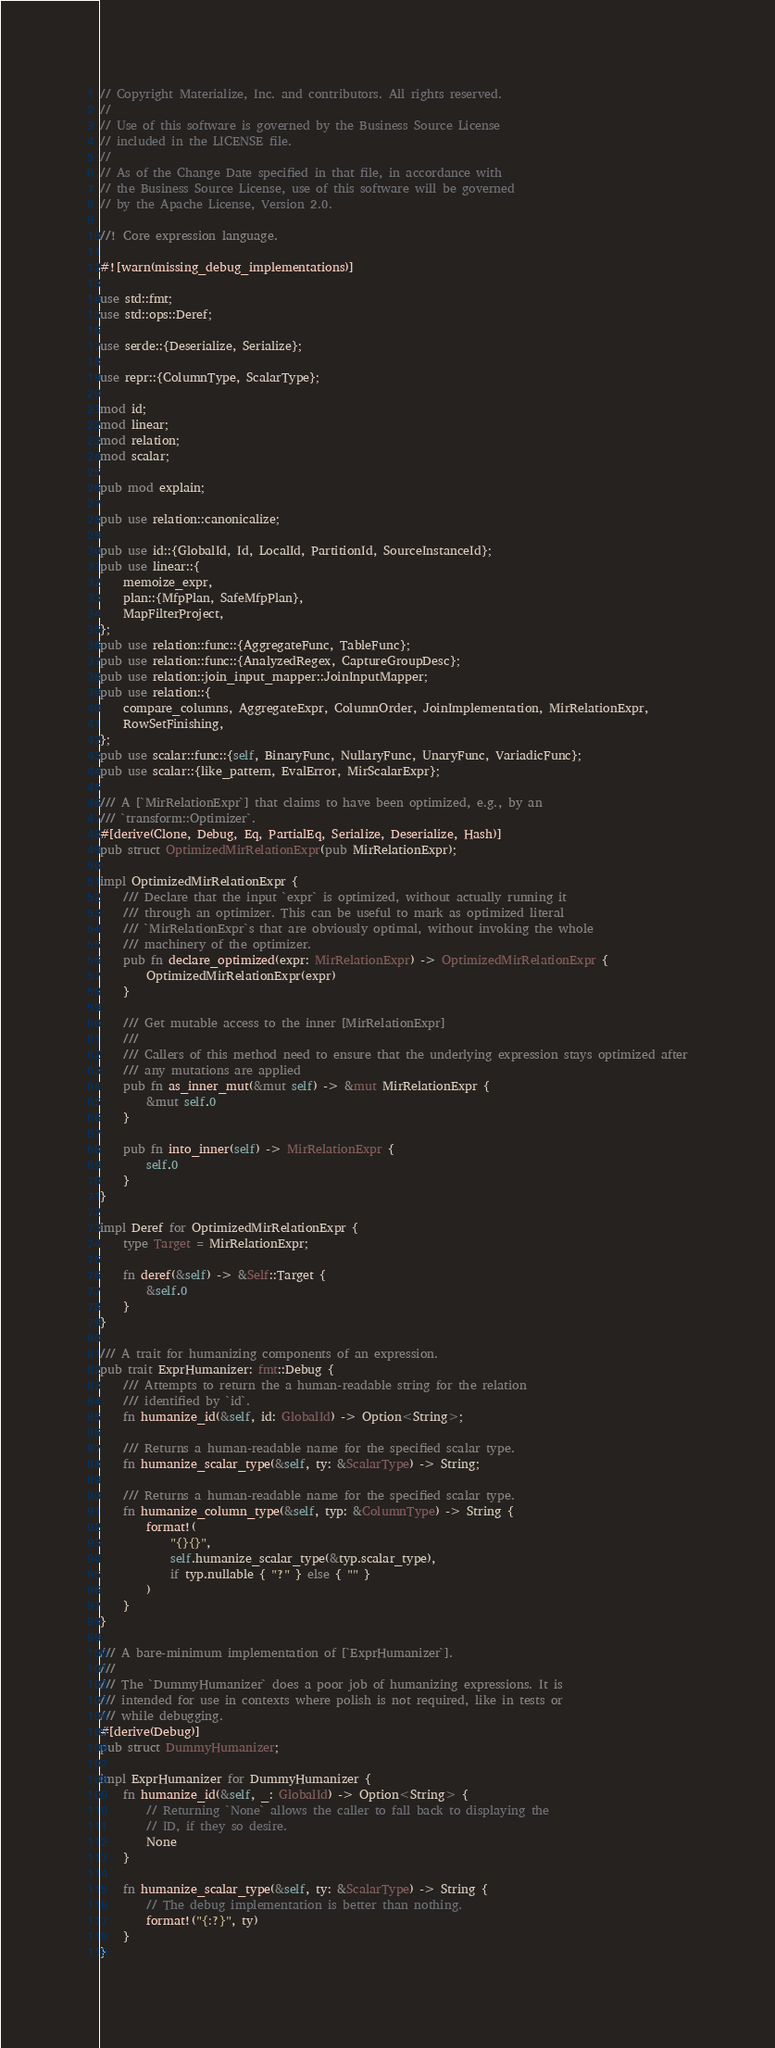<code> <loc_0><loc_0><loc_500><loc_500><_Rust_>// Copyright Materialize, Inc. and contributors. All rights reserved.
//
// Use of this software is governed by the Business Source License
// included in the LICENSE file.
//
// As of the Change Date specified in that file, in accordance with
// the Business Source License, use of this software will be governed
// by the Apache License, Version 2.0.

//! Core expression language.

#![warn(missing_debug_implementations)]

use std::fmt;
use std::ops::Deref;

use serde::{Deserialize, Serialize};

use repr::{ColumnType, ScalarType};

mod id;
mod linear;
mod relation;
mod scalar;

pub mod explain;

pub use relation::canonicalize;

pub use id::{GlobalId, Id, LocalId, PartitionId, SourceInstanceId};
pub use linear::{
    memoize_expr,
    plan::{MfpPlan, SafeMfpPlan},
    MapFilterProject,
};
pub use relation::func::{AggregateFunc, TableFunc};
pub use relation::func::{AnalyzedRegex, CaptureGroupDesc};
pub use relation::join_input_mapper::JoinInputMapper;
pub use relation::{
    compare_columns, AggregateExpr, ColumnOrder, JoinImplementation, MirRelationExpr,
    RowSetFinishing,
};
pub use scalar::func::{self, BinaryFunc, NullaryFunc, UnaryFunc, VariadicFunc};
pub use scalar::{like_pattern, EvalError, MirScalarExpr};

/// A [`MirRelationExpr`] that claims to have been optimized, e.g., by an
/// `transform::Optimizer`.
#[derive(Clone, Debug, Eq, PartialEq, Serialize, Deserialize, Hash)]
pub struct OptimizedMirRelationExpr(pub MirRelationExpr);

impl OptimizedMirRelationExpr {
    /// Declare that the input `expr` is optimized, without actually running it
    /// through an optimizer. This can be useful to mark as optimized literal
    /// `MirRelationExpr`s that are obviously optimal, without invoking the whole
    /// machinery of the optimizer.
    pub fn declare_optimized(expr: MirRelationExpr) -> OptimizedMirRelationExpr {
        OptimizedMirRelationExpr(expr)
    }

    /// Get mutable access to the inner [MirRelationExpr]
    ///
    /// Callers of this method need to ensure that the underlying expression stays optimized after
    /// any mutations are applied
    pub fn as_inner_mut(&mut self) -> &mut MirRelationExpr {
        &mut self.0
    }

    pub fn into_inner(self) -> MirRelationExpr {
        self.0
    }
}

impl Deref for OptimizedMirRelationExpr {
    type Target = MirRelationExpr;

    fn deref(&self) -> &Self::Target {
        &self.0
    }
}

/// A trait for humanizing components of an expression.
pub trait ExprHumanizer: fmt::Debug {
    /// Attempts to return the a human-readable string for the relation
    /// identified by `id`.
    fn humanize_id(&self, id: GlobalId) -> Option<String>;

    /// Returns a human-readable name for the specified scalar type.
    fn humanize_scalar_type(&self, ty: &ScalarType) -> String;

    /// Returns a human-readable name for the specified scalar type.
    fn humanize_column_type(&self, typ: &ColumnType) -> String {
        format!(
            "{}{}",
            self.humanize_scalar_type(&typ.scalar_type),
            if typ.nullable { "?" } else { "" }
        )
    }
}

/// A bare-minimum implementation of [`ExprHumanizer`].
///
/// The `DummyHumanizer` does a poor job of humanizing expressions. It is
/// intended for use in contexts where polish is not required, like in tests or
/// while debugging.
#[derive(Debug)]
pub struct DummyHumanizer;

impl ExprHumanizer for DummyHumanizer {
    fn humanize_id(&self, _: GlobalId) -> Option<String> {
        // Returning `None` allows the caller to fall back to displaying the
        // ID, if they so desire.
        None
    }

    fn humanize_scalar_type(&self, ty: &ScalarType) -> String {
        // The debug implementation is better than nothing.
        format!("{:?}", ty)
    }
}
</code> 